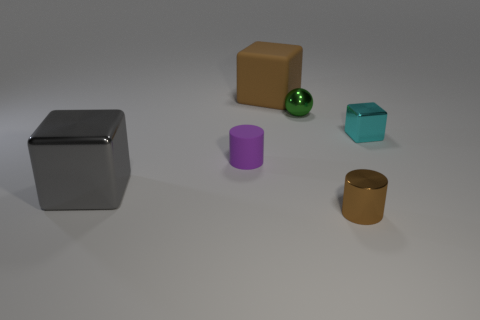Add 2 small red cubes. How many objects exist? 8 Subtract all balls. How many objects are left? 5 Add 4 big brown things. How many big brown things exist? 5 Subtract 0 yellow blocks. How many objects are left? 6 Subtract all small green spheres. Subtract all small shiny cylinders. How many objects are left? 4 Add 2 green metal spheres. How many green metal spheres are left? 3 